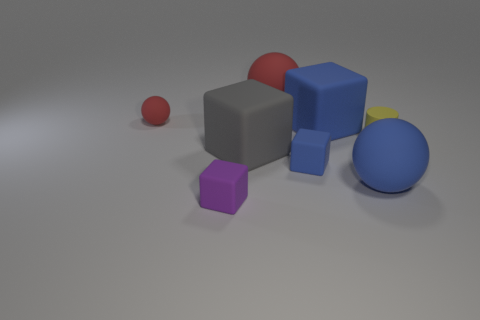What number of brown matte cylinders are there?
Your answer should be compact. 0. Are there any tiny purple blocks made of the same material as the small blue block?
Your answer should be very brief. Yes. What is the size of the other rubber ball that is the same color as the small sphere?
Give a very brief answer. Large. There is a rubber cylinder that is behind the big blue ball; does it have the same size as the ball behind the small ball?
Ensure brevity in your answer.  No. How big is the red thing on the left side of the big gray cube?
Your response must be concise. Small. Are there any other spheres of the same color as the small ball?
Keep it short and to the point. Yes. Is there a tiny object that is on the left side of the tiny matte block that is on the right side of the purple object?
Provide a succinct answer. Yes. Does the yellow rubber object have the same size as the cube to the left of the big gray rubber object?
Make the answer very short. Yes. Are there any large blue blocks that are on the left side of the matte block that is in front of the blue matte object right of the big blue matte cube?
Offer a terse response. No. There is a red thing right of the tiny purple block; what material is it?
Your response must be concise. Rubber. 